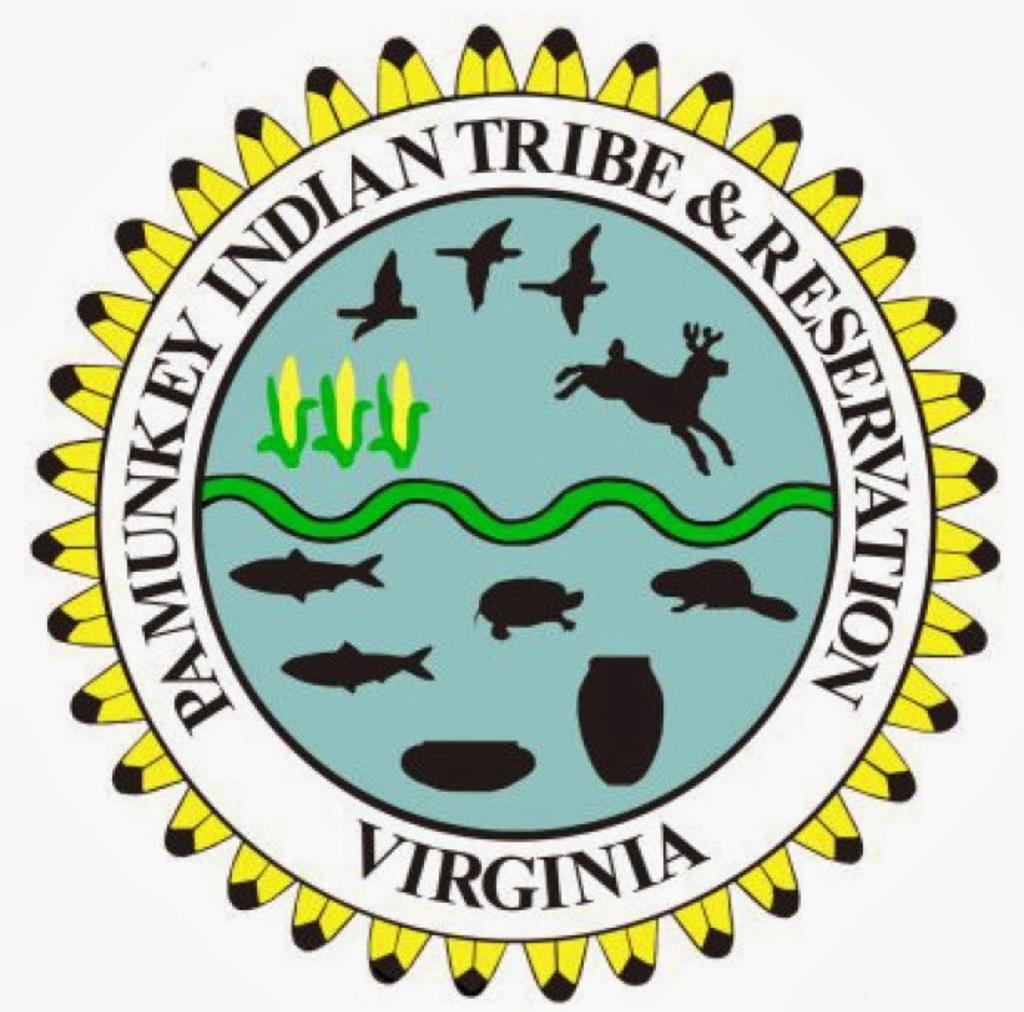How would you summarize this image in a sentence or two? This is a logo with something written on that. In this logo there are drawings of corns, birds, animals, fishes and pots 